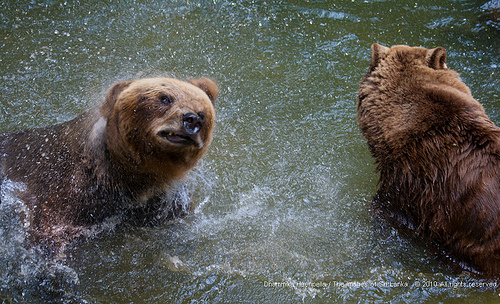<image>
Is there a bear behind the bear? No. The bear is not behind the bear. From this viewpoint, the bear appears to be positioned elsewhere in the scene. 